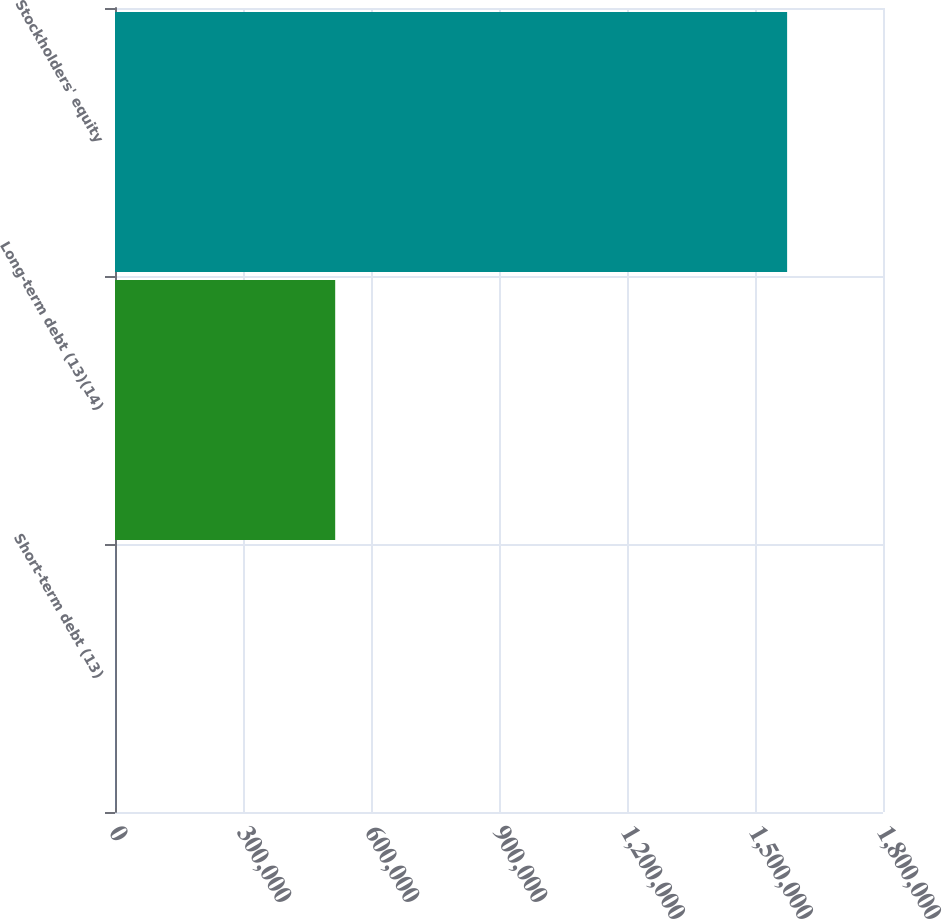Convert chart to OTSL. <chart><loc_0><loc_0><loc_500><loc_500><bar_chart><fcel>Short-term debt (13)<fcel>Long-term debt (13)(14)<fcel>Stockholders' equity<nl><fcel>562<fcel>516078<fcel>1.57528e+06<nl></chart> 